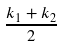Convert formula to latex. <formula><loc_0><loc_0><loc_500><loc_500>\frac { k _ { 1 } + k _ { 2 } } { 2 }</formula> 